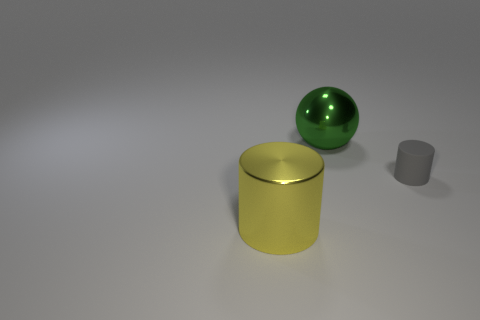How many big objects are metal spheres or gray rubber blocks?
Give a very brief answer. 1. How many other yellow things have the same material as the yellow object?
Offer a very short reply. 0. How many green objects are either large objects or tiny matte cylinders?
Your response must be concise. 1. Are there any other things that are the same material as the tiny object?
Offer a terse response. No. Do the large object on the left side of the large sphere and the ball have the same material?
Keep it short and to the point. Yes. How many objects are green spheres or objects that are right of the large green metallic thing?
Ensure brevity in your answer.  2. How many big yellow metallic objects are right of the large object that is in front of the big object that is behind the shiny cylinder?
Offer a very short reply. 0. Do the shiny object behind the big yellow metal cylinder and the yellow object have the same shape?
Give a very brief answer. No. Is there a gray cylinder that is to the right of the large object left of the large green metallic thing?
Ensure brevity in your answer.  Yes. What number of tiny gray rubber things are there?
Make the answer very short. 1. 